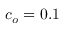Convert formula to latex. <formula><loc_0><loc_0><loc_500><loc_500>c _ { o } = 0 . 1</formula> 